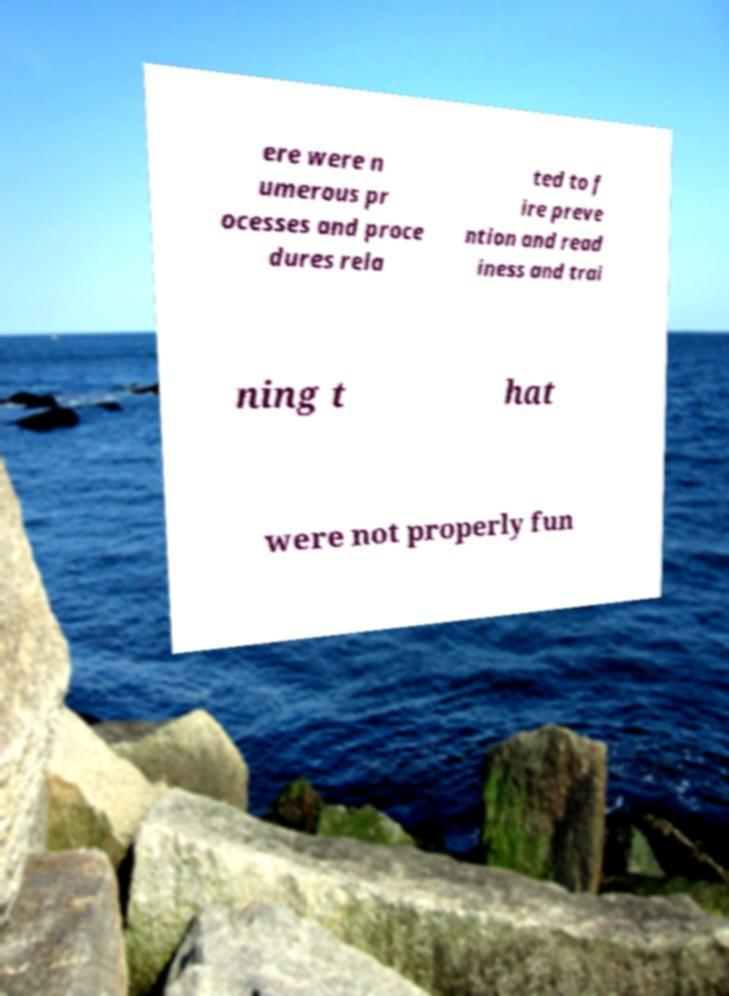Could you extract and type out the text from this image? ere were n umerous pr ocesses and proce dures rela ted to f ire preve ntion and read iness and trai ning t hat were not properly fun 